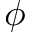<formula> <loc_0><loc_0><loc_500><loc_500>\phi</formula> 